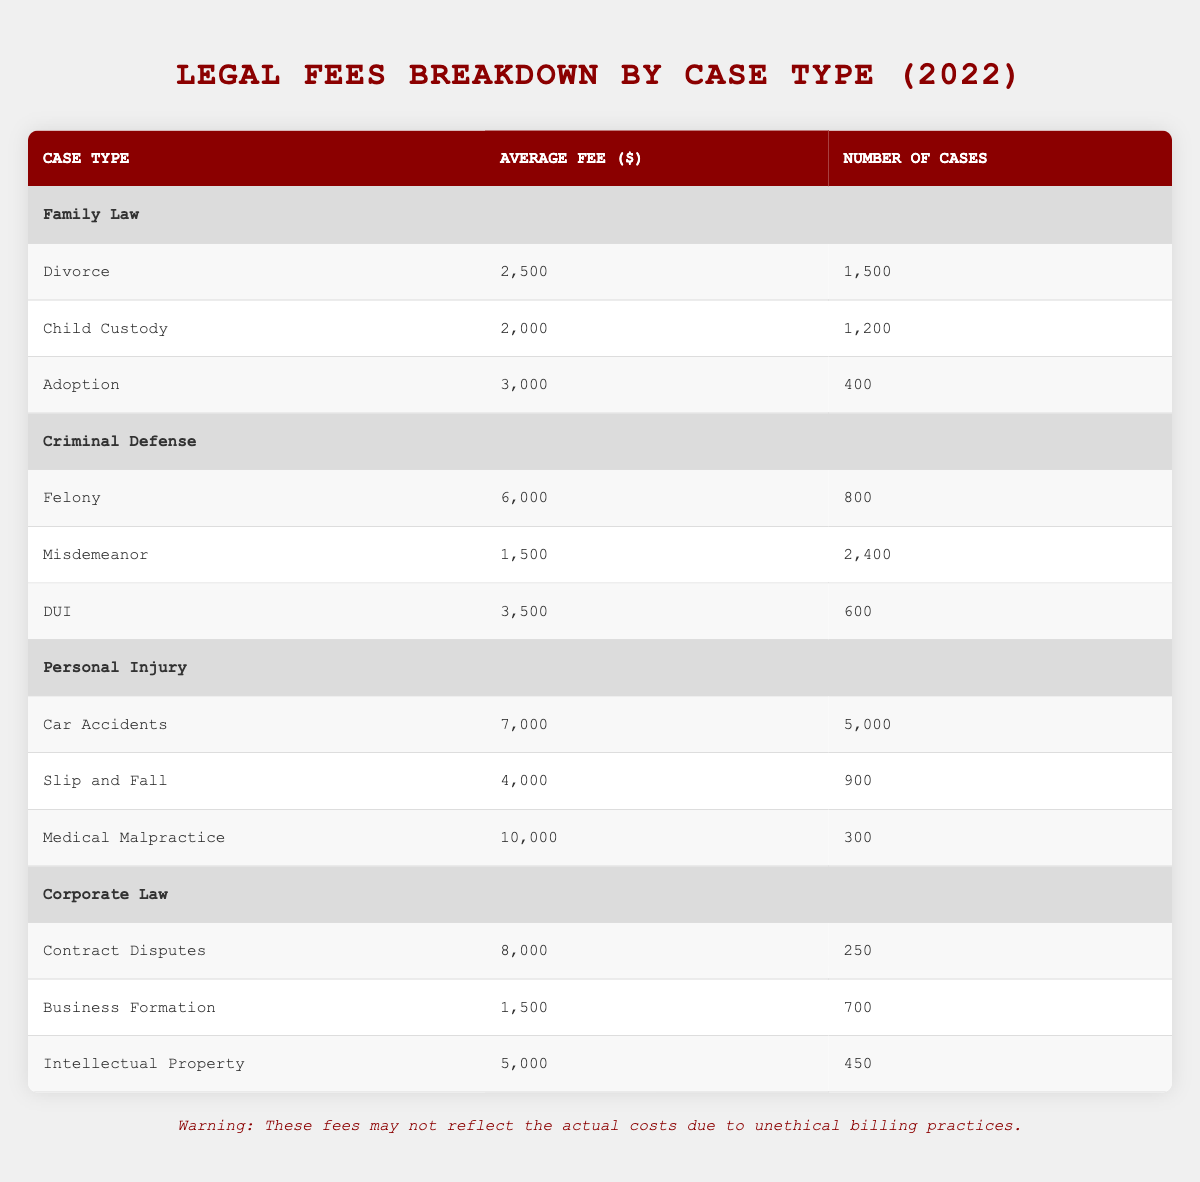What's the average fee for a Divorce case? The table lists the Divorce average fee under Family Law as 2,500.
Answer: 2,500 How many Child Custody cases were filed in 2022? The table shows that there were 1,200 Child Custody cases under Family Law.
Answer: 1,200 Is the average fee for a DUI case higher than for a Misdemeanor case? The average fee for DUI is 3,500 and for Misdemeanor is 1,500. Since 3,500 is greater than 1,500, the statement is true.
Answer: Yes What is the combined average fee for all Personal Injury cases? To find the combined average fee, calculate the total fees: (7,000 * 5,000 + 4,000 * 900 + 10,000 * 300) = 35,000,000 + 3,600,000 + 3,000,000 = 41,600,000. The total number of cases is (5,000 + 900 + 300) = 6,200. Then divide the total fees by total cases: 41,600,000 / 6,200 = 6,710. In this case, the combined average fee is approximately 6,710.
Answer: 6,710 Was the average fee for Medical Malpractice higher than the average fee for Contract Disputes? The average fee for Medical Malpractice is 10,000 and for Contract Disputes it's 8,000. Since 10,000 is greater than 8,000, the statement is true.
Answer: Yes What is the total number of cases across all types of Criminal Defense? The total number of cases is calculated by summing each category: 800 for Felony + 2,400 for Misdemeanor + 600 for DUI = 3,800.
Answer: 3,800 Which case type had the highest average fee in the table? Reference the average fees listed: the highest fee of 10,000 for Medical Malpractice is greater than others in the table.
Answer: Medical Malpractice How does the average fee for a Slip and Fall case compare to the average fee for an Adoption case? The average fee for a Slip and Fall case is 4,000, while for Adoption it is 3,000. Since 4,000 is greater than 3,000, Slip and Fall has a higher average fee.
Answer: Higher What percentage of Family Law cases were Divorce cases? The total number of Family Law cases is (1,500 + 1,200 + 400) = 3,100, and Divorce cases are 1,500. Calculate the percentage: (1,500 / 3,100) * 100 = 48.39%.
Answer: 48.39% 